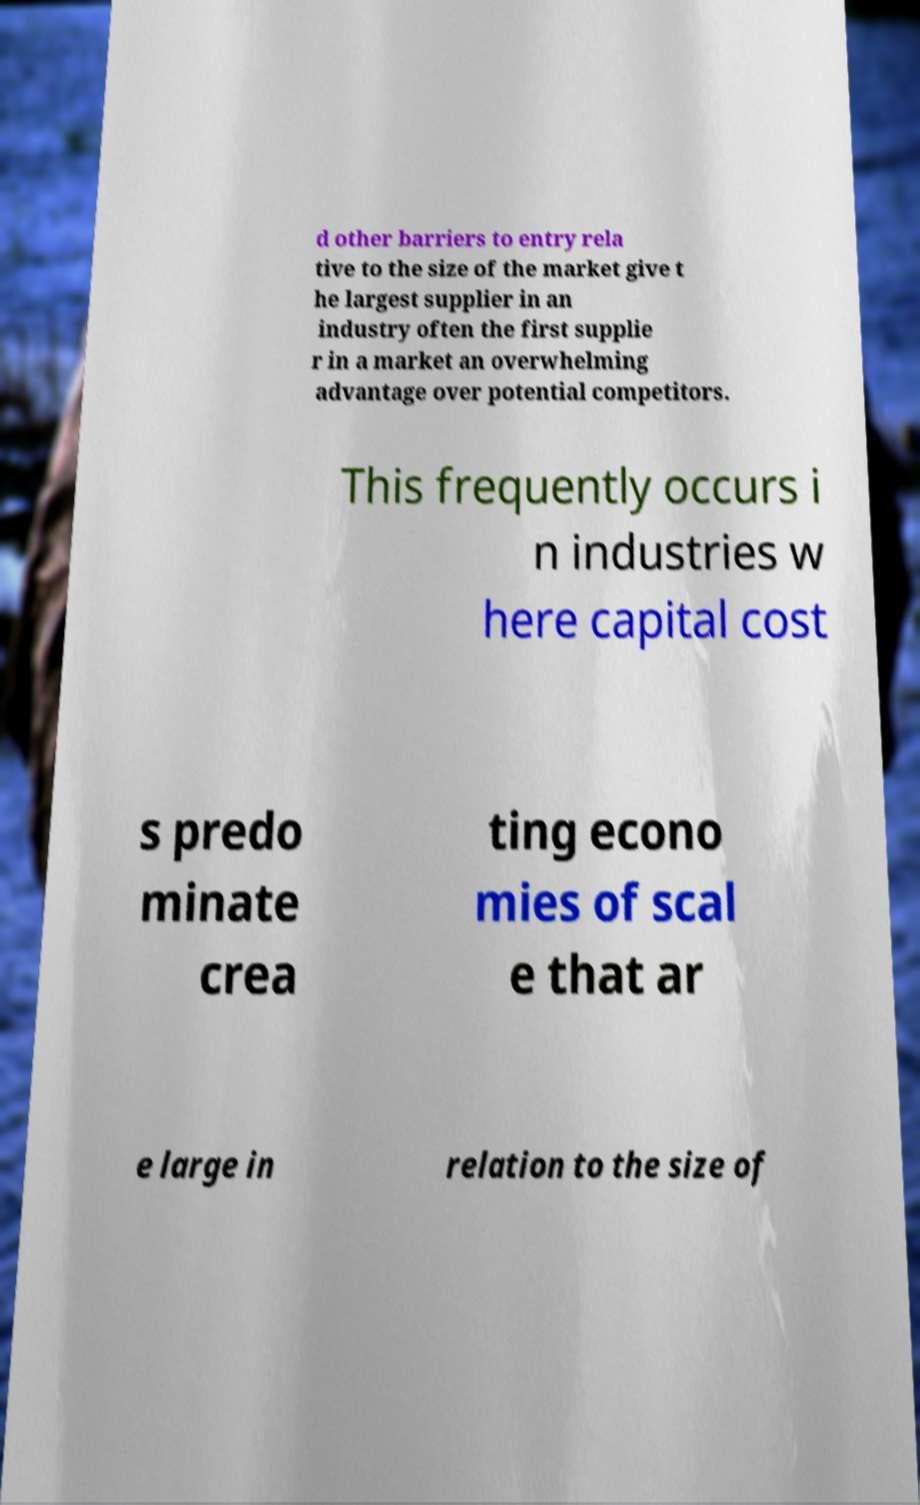For documentation purposes, I need the text within this image transcribed. Could you provide that? d other barriers to entry rela tive to the size of the market give t he largest supplier in an industry often the first supplie r in a market an overwhelming advantage over potential competitors. This frequently occurs i n industries w here capital cost s predo minate crea ting econo mies of scal e that ar e large in relation to the size of 